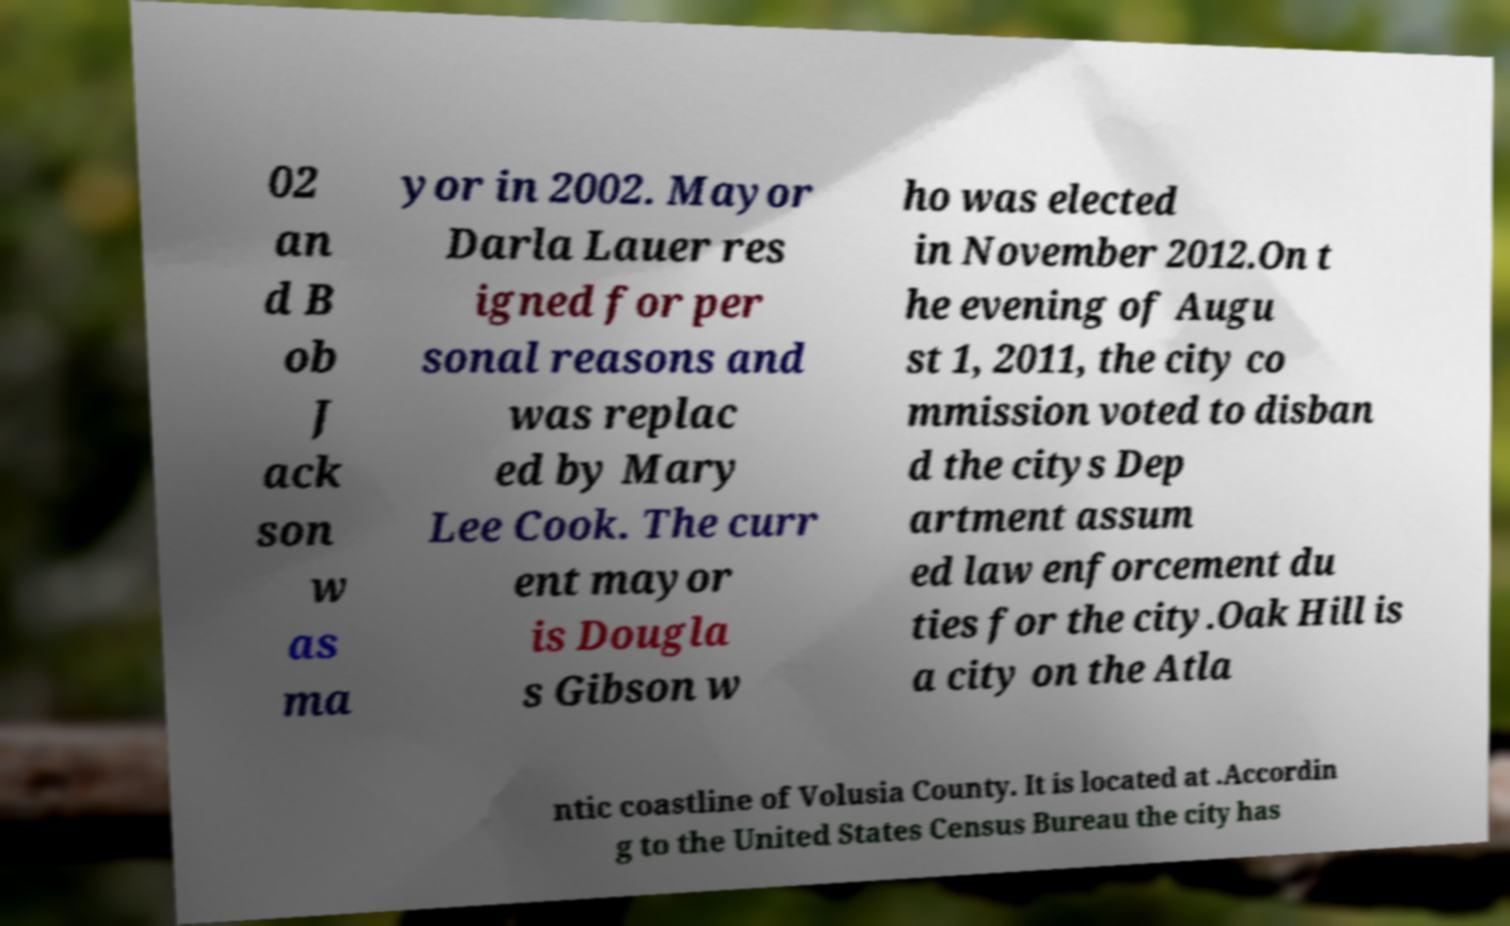Could you extract and type out the text from this image? 02 an d B ob J ack son w as ma yor in 2002. Mayor Darla Lauer res igned for per sonal reasons and was replac ed by Mary Lee Cook. The curr ent mayor is Dougla s Gibson w ho was elected in November 2012.On t he evening of Augu st 1, 2011, the city co mmission voted to disban d the citys Dep artment assum ed law enforcement du ties for the city.Oak Hill is a city on the Atla ntic coastline of Volusia County. It is located at .Accordin g to the United States Census Bureau the city has 